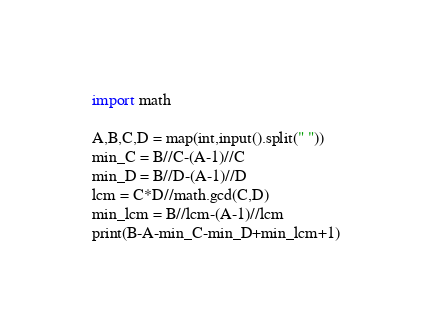Convert code to text. <code><loc_0><loc_0><loc_500><loc_500><_Python_>import math

A,B,C,D = map(int,input().split(" "))
min_C = B//C-(A-1)//C
min_D = B//D-(A-1)//D
lcm = C*D//math.gcd(C,D)
min_lcm = B//lcm-(A-1)//lcm
print(B-A-min_C-min_D+min_lcm+1)

</code> 